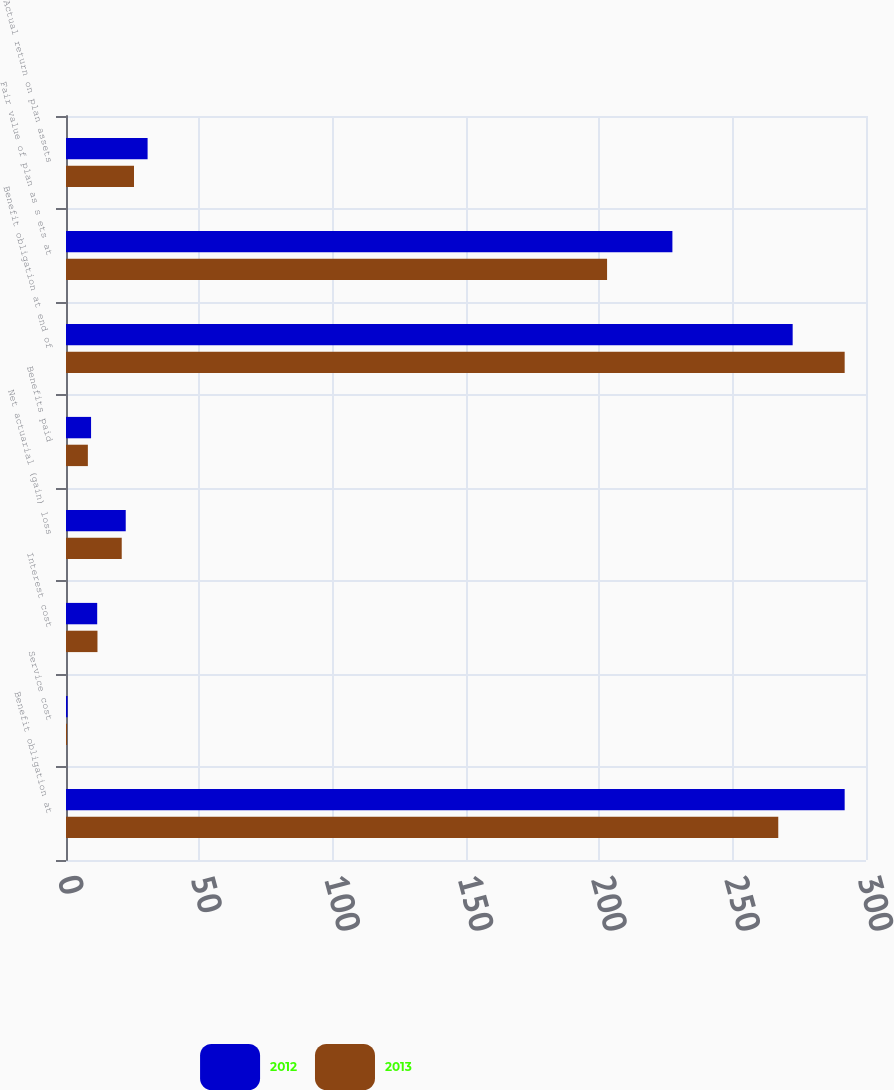Convert chart to OTSL. <chart><loc_0><loc_0><loc_500><loc_500><stacked_bar_chart><ecel><fcel>Benefit obligation at<fcel>Service cost<fcel>Interest cost<fcel>Net actuarial (gain) loss<fcel>Benefits paid<fcel>Benefit obligation at end of<fcel>Fair value of plan as s ets at<fcel>Actual return on plan assets<nl><fcel>2012<fcel>292<fcel>0.6<fcel>11.7<fcel>22.4<fcel>9.4<fcel>272.5<fcel>227.4<fcel>30.6<nl><fcel>2013<fcel>267.1<fcel>0.4<fcel>11.8<fcel>20.9<fcel>8.2<fcel>292<fcel>202.9<fcel>25.5<nl></chart> 